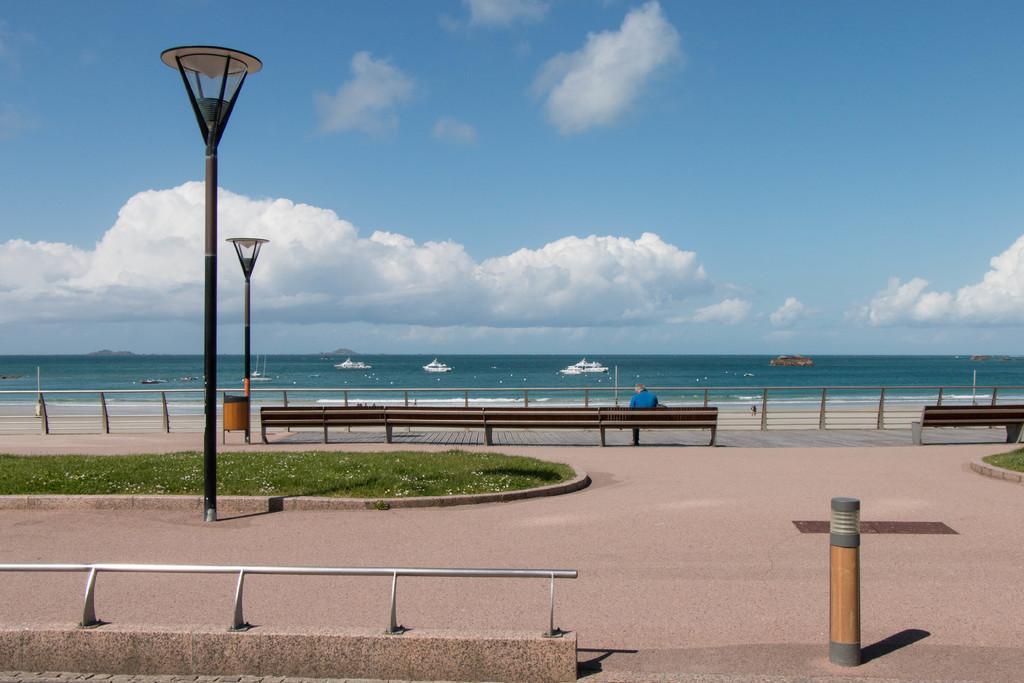Could you give a brief overview of what you see in this image? In this picture there is a person sitting on the bench. There are benches and there are street lights and there is a railing. At the back there are boats on the water and there are mountains. At the top there is sky and there are clouds. At the bottom there is water and there is a road and there is grass. 